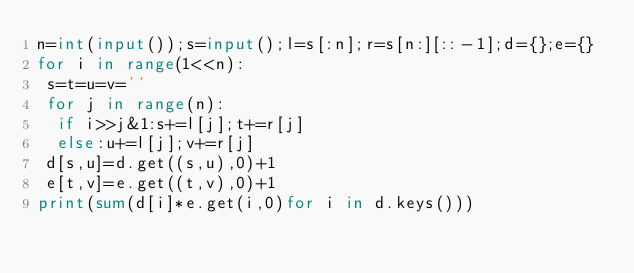<code> <loc_0><loc_0><loc_500><loc_500><_Python_>n=int(input());s=input();l=s[:n];r=s[n:][::-1];d={};e={}
for i in range(1<<n):
 s=t=u=v=''
 for j in range(n):
  if i>>j&1:s+=l[j];t+=r[j]
  else:u+=l[j];v+=r[j]
 d[s,u]=d.get((s,u),0)+1
 e[t,v]=e.get((t,v),0)+1
print(sum(d[i]*e.get(i,0)for i in d.keys()))</code> 